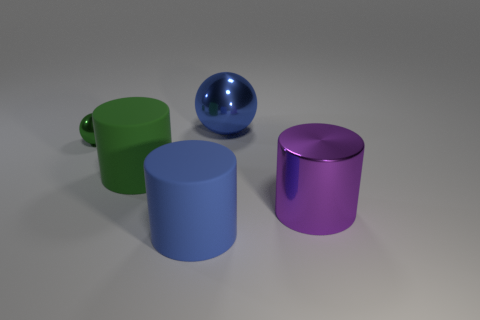Add 4 tiny brown blocks. How many objects exist? 9 Subtract all balls. How many objects are left? 3 Add 3 metallic spheres. How many metallic spheres are left? 5 Add 5 tiny shiny things. How many tiny shiny things exist? 6 Subtract 1 green balls. How many objects are left? 4 Subtract all metal cylinders. Subtract all large green objects. How many objects are left? 3 